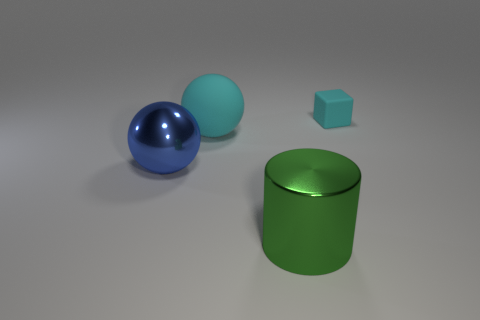Are there an equal number of small cyan cubes that are to the left of the tiny thing and tiny rubber blocks that are in front of the green thing?
Your answer should be very brief. Yes. There is a thing that is right of the big cyan matte sphere and left of the tiny object; what is it made of?
Your answer should be very brief. Metal. There is a rubber block; is its size the same as the metal object left of the big green shiny object?
Provide a short and direct response. No. How many other objects are the same color as the tiny rubber cube?
Your answer should be very brief. 1. Is the number of rubber objects right of the large green object greater than the number of large cyan objects?
Offer a terse response. No. What color is the rubber object to the right of the green metal object that is left of the cyan rubber thing that is behind the big matte object?
Ensure brevity in your answer.  Cyan. Are the cyan block and the large green cylinder made of the same material?
Offer a terse response. No. Is there a cyan matte object of the same size as the cyan sphere?
Provide a succinct answer. No. What material is the blue ball that is the same size as the green metallic thing?
Your answer should be compact. Metal. Is there a large blue object that has the same shape as the green shiny object?
Keep it short and to the point. No. 